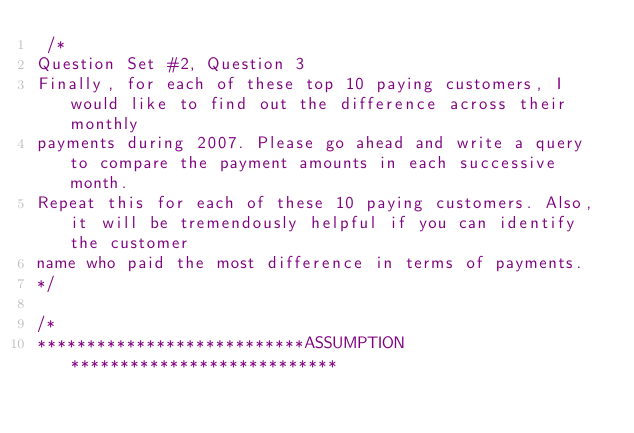<code> <loc_0><loc_0><loc_500><loc_500><_SQL_> /*
Question Set #2, Question 3
Finally, for each of these top 10 paying customers, I would like to find out the difference across their monthly
payments during 2007. Please go ahead and write a query to compare the payment amounts in each successive month. 
Repeat this for each of these 10 paying customers. Also, it will be tremendously helpful if you can identify the customer 
name who paid the most difference in terms of payments.
*/

/*
***************************ASSUMPTION***************************</code> 